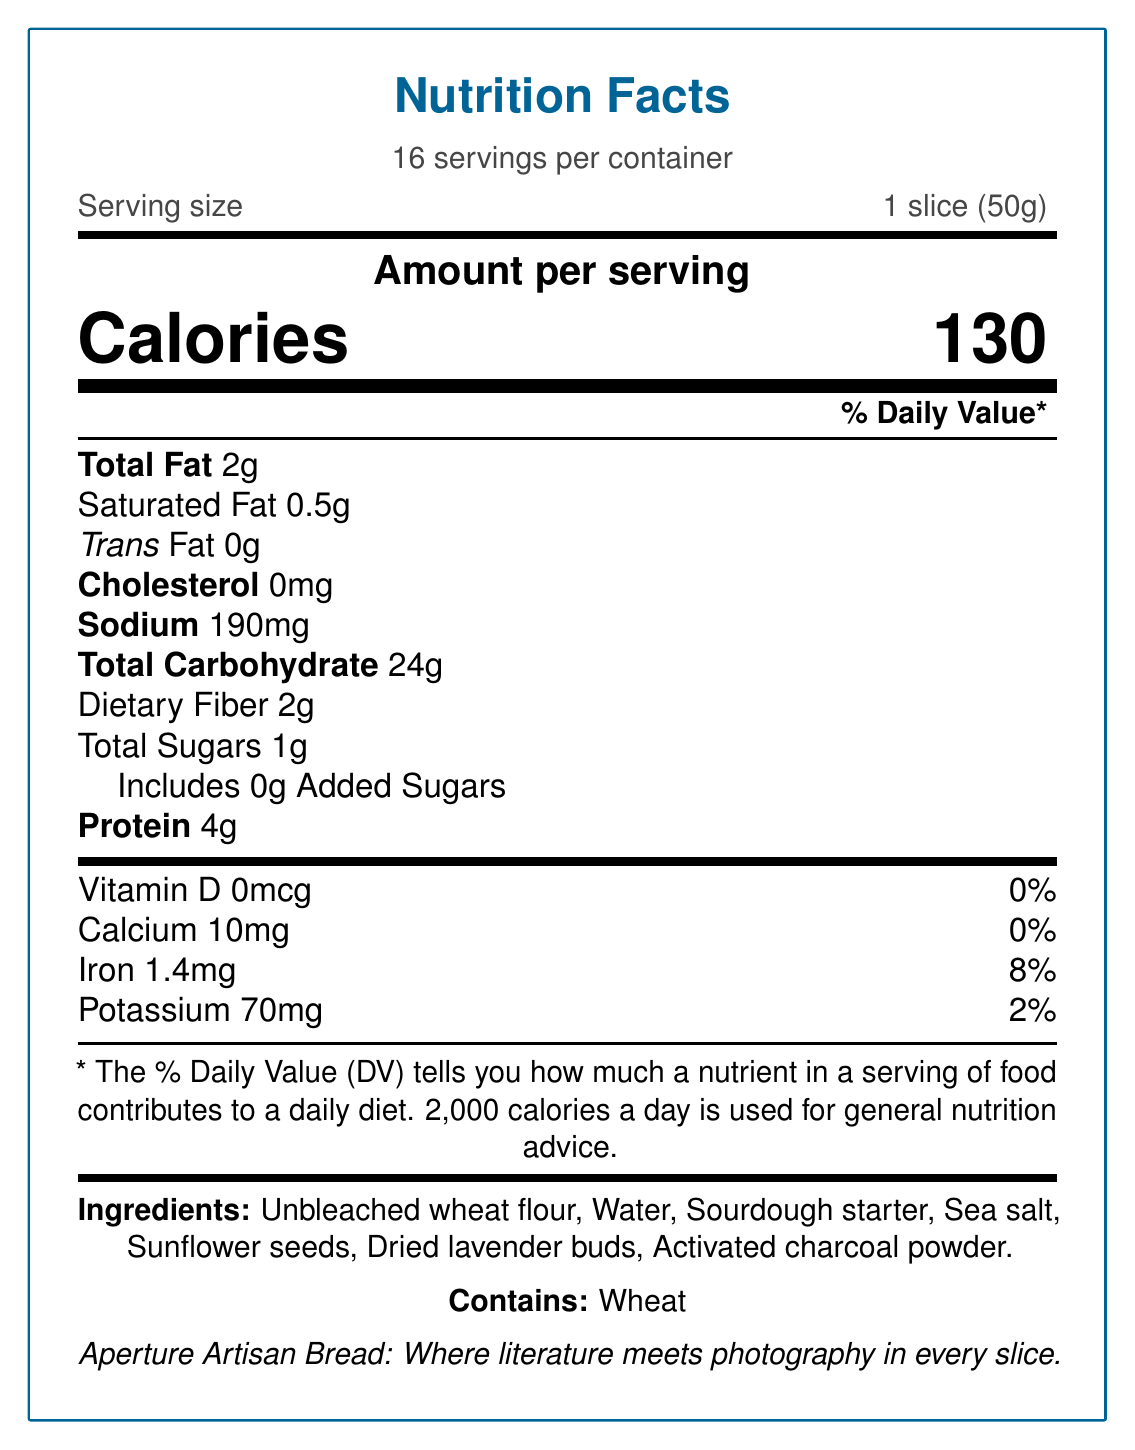what is the serving size? The serving size is specified as "1 slice (50g)" under the section stating "Serving size".
Answer: 1 slice (50g) how many calories are there per serving? The document lists "Calories 130" under the "Amount per serving" section.
Answer: 130 what is the percentage of daily value for sodium? The daily value percentage for sodium is listed as 8% next to "Sodium 190mg".
Answer: 8% how much dietary fiber is in one serving? The amount of dietary fiber per serving is listed as "Dietary Fiber 2g".
Answer: 2g what ingredients are used in the bread? The ingredients are listed under the "Ingredients" section.
Answer: Unbleached wheat flour, Water, Sourdough starter, Sea salt, Sunflower seeds, Dried lavender buds, Activated charcoal powder what is the main inspiration behind the name "Aperture Artisan Bread"? A. A culinary technique B. A photography term C. A famous painting D. An ancient tool The name "Aperture Artisan Bread" is inspired by the photography term, mentioned in the section explaining the literary connection.
Answer: B how long is the bread slow-fermented? A. 12 hours B. 24 hours C. 36 hours D. 48 hours The bread is slow-fermented for 24 hours as stated in the "baking process" section.
Answer: B does the bread contain any trans fat? The document states "Trans Fat 0g" indicating that there is no trans fat in the bread.
Answer: No is this bread suitable for someone with a wheat allergy? The document clearly states "Contains wheat" under the allergens section.
Answer: No describe the entire document The document is an extensive nutrition facts label offering comprehensive data about "Aperture Artisan Bread", including its nutritional content, ingredients, allergens, literary and photographic inspirations, storage instructions, baking process, and sustainability efforts.
Answer: The document provides detailed nutritional information and ingredient list for "Aperture Artisan Bread". It includes serving size, calories, macronutrients, vitamins, and minerals. Additionally, it elaborates on the unique photography-inspired ingredients and literary connections of the bread. The document also contains storage instructions, baking process description, and sustainability notes. what is the daily value percentage for iron? The daily value for iron is listed as 8% right next to "Iron 1.4mg".
Answer: 8% what does the activated charcoal powder represent? The "photography_inspired_elements" section states that activated charcoal powder creates a dark contrast like shadows in black and white photography.
Answer: The dark contrast like shadows in black and white photography how many servings are there per container? The document states "16 servings per container" under the servings information.
Answer: 16 how much potassium is in one serving? The amount of potassium per serving is listed as "Potassium 70mg".
Answer: 70mg what is the percentage of daily value for vitamin D? The document lists "Vitamin D 0mcg" and "0%" under daily value percentages.
Answer: 0% which ingredient is used to add a purple tint reminiscent of color filters? A. Sunflower seeds B. Dried lavender buds C. Activated charcoal powder D. Sea salt Dried lavender buds are noted to add a purple tint reminiscent of color filters in the photography-inspired elements section.
Answer: B what is the daily value percentage for total carbohydrate? The daily value percentage for total carbohydrate is listed as 9% next to "Total Carbohydrate 24g".
Answer: 9% does the package contain recycled material? The sustainability note mentions that the packaging is made from recycled paper.
Answer: Yes what is the amount of total sugars in one serving? The amount of total sugars per serving is listed as "Total Sugars 1g".
Answer: 1g what is the daily value percentage for calcium? The daily value percentage for calcium is listed as 0% next to "Calcium 10mg".
Answer: 0% what is the main idea behind the document? The document aims to present detailed nutritional information, ingredient insights, and the artistic and environmental inspirations behind "Aperture Artisan Bread".
Answer: The document provides nutritional data, ingredients, and unique inspirations for "Aperture Artisan Bread", linking culinary arts with photography and literature. which type of flour is used in the bread? The ingredient list specifies "Unbleached wheat flour".
Answer: Unbleached wheat flour what storage instructions are given for the bread? The storage instructions section advises to "Store in a cool, dry place" and to consume the bread within 3 days of purchase.
Answer: Store in a cool, dry place. Best if consumed within 3 days of purchase. what is the percentage of daily value for added sugars? The document states "Includes 0g Added Sugars" with a daily value percentage of 0%.
Answer: 0% how does the packaging of the bread connect to the theme of sustainability? The sustainability note explains that the packaging is made from recycled paper, inspired by themes in nature photography and eco-conscious literature.
Answer: Packaging made from recycled paper, inspired by environmental themes in nature photography and eco-conscious literature. what is the baking process for this bread? The document mentions a slow-fermentation process of 24 hours to develop complex flavors, drawing a parallel to the patience required in literature and photography.
Answer: Slow-fermented for 24 hours to develop complex flavors, reminiscent of the patience required in both literature and photography. which literary work is mentioned in the document? The document notes that "Aperture Artisan Bread" alludes to James Joyce's "A Portrait of the Artist as a Young Man".
Answer: James Joyce's "A Portrait of the Artist as a Young Man" how much saturated fat is in one serving? The amount of saturated fat per serving is listed as "Saturated Fat 0.5g".
Answer: 0.5g what is the unique element that represents golden hour lighting? The document states that sunflower seeds represent golden hour lighting.
Answer: Sunflower seeds what percentage of daily nutrition does dietary fiber contribute to? The daily value percentage for dietary fiber is 7%, as indicated next to "Dietary Fiber 2g".
Answer: 7% what is the total amount of protein in one serving? The amount of protein per serving is listed as "Protein 4g".
Answer: 4g how many servings should be consumed daily for general nutrition advice? The document states that 2,000 calories a day is used for general nutrition advice, but it doesn't specify the number of servings of this particular bread to consume daily.
Answer: Cannot be determined 